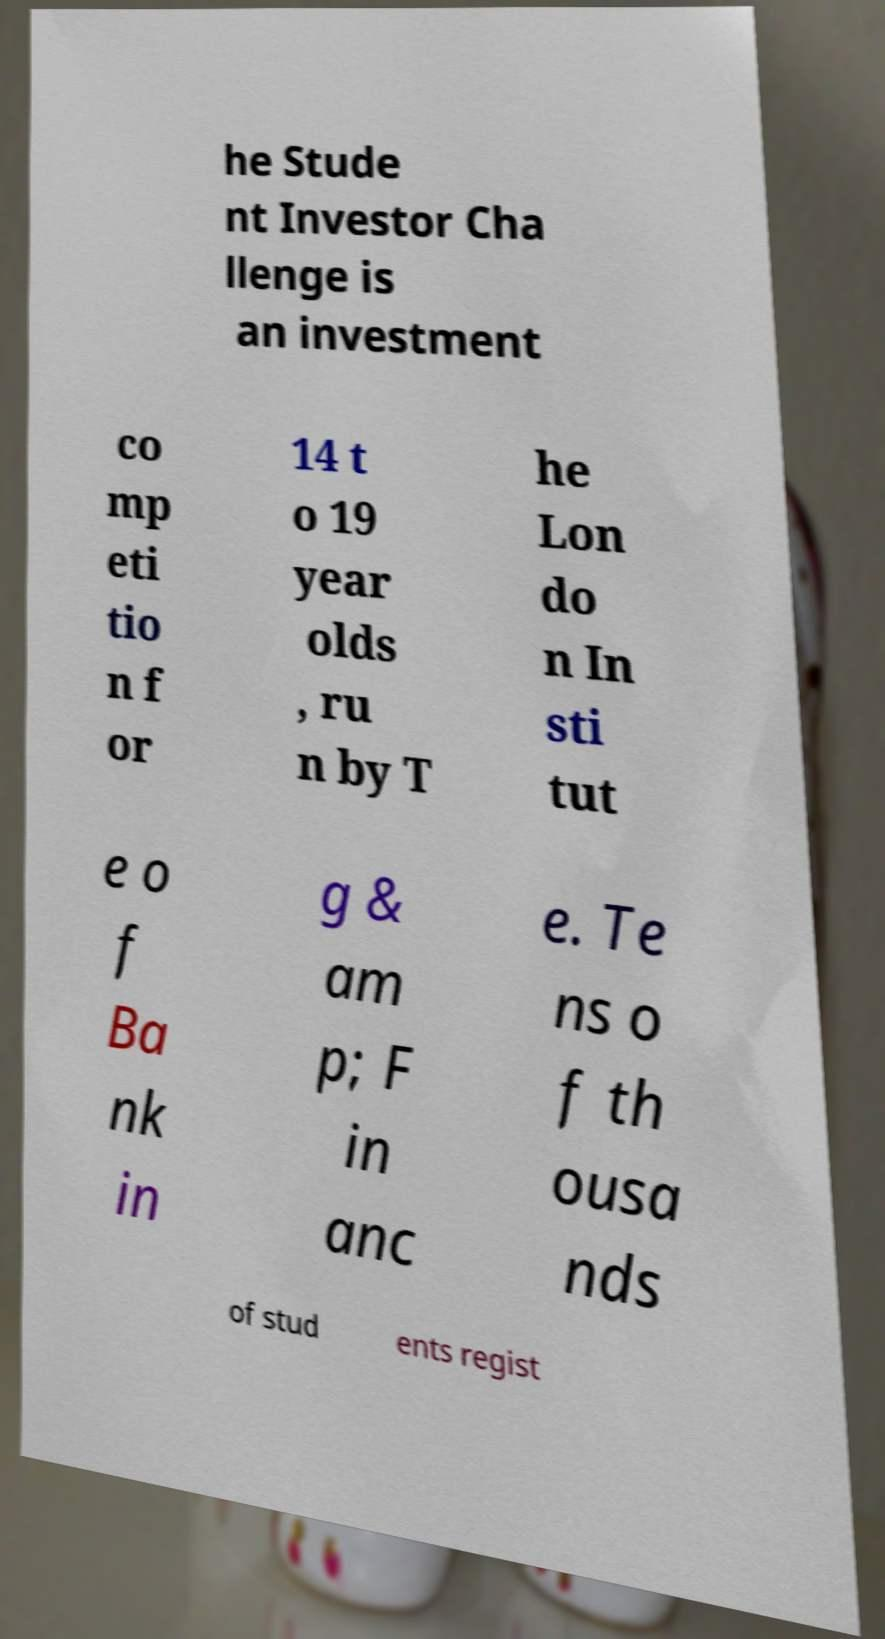Please read and relay the text visible in this image. What does it say? he Stude nt Investor Cha llenge is an investment co mp eti tio n f or 14 t o 19 year olds , ru n by T he Lon do n In sti tut e o f Ba nk in g & am p; F in anc e. Te ns o f th ousa nds of stud ents regist 